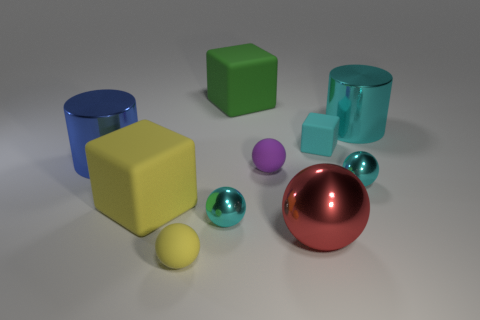Subtract 2 balls. How many balls are left? 3 Subtract all red spheres. How many spheres are left? 4 Subtract all green spheres. Subtract all yellow cylinders. How many spheres are left? 5 Subtract all cubes. How many objects are left? 7 Subtract all big cyan metallic cylinders. Subtract all cyan rubber cubes. How many objects are left? 8 Add 1 small purple spheres. How many small purple spheres are left? 2 Add 3 small balls. How many small balls exist? 7 Subtract 1 yellow spheres. How many objects are left? 9 